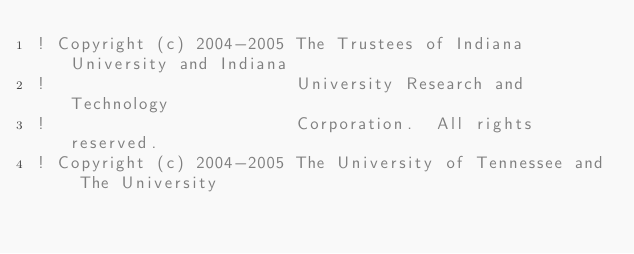<code> <loc_0><loc_0><loc_500><loc_500><_FORTRAN_>! Copyright (c) 2004-2005 The Trustees of Indiana University and Indiana
!                         University Research and Technology
!                         Corporation.  All rights reserved.
! Copyright (c) 2004-2005 The University of Tennessee and The University</code> 